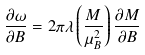<formula> <loc_0><loc_0><loc_500><loc_500>\frac { \partial \omega } { \partial B } = 2 \pi \lambda \left ( \frac { M } { \mu _ { B } ^ { 2 } } \right ) \frac { \partial M } { \partial B }</formula> 